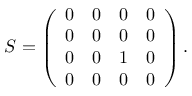<formula> <loc_0><loc_0><loc_500><loc_500>\begin{array} { r } { S = \left ( \begin{array} { l l l l } { 0 } & { 0 } & { 0 } & { 0 } \\ { 0 } & { 0 } & { 0 } & { 0 } \\ { 0 } & { 0 } & { 1 } & { 0 } \\ { 0 } & { 0 } & { 0 } & { 0 } \end{array} \right ) . } \end{array}</formula> 